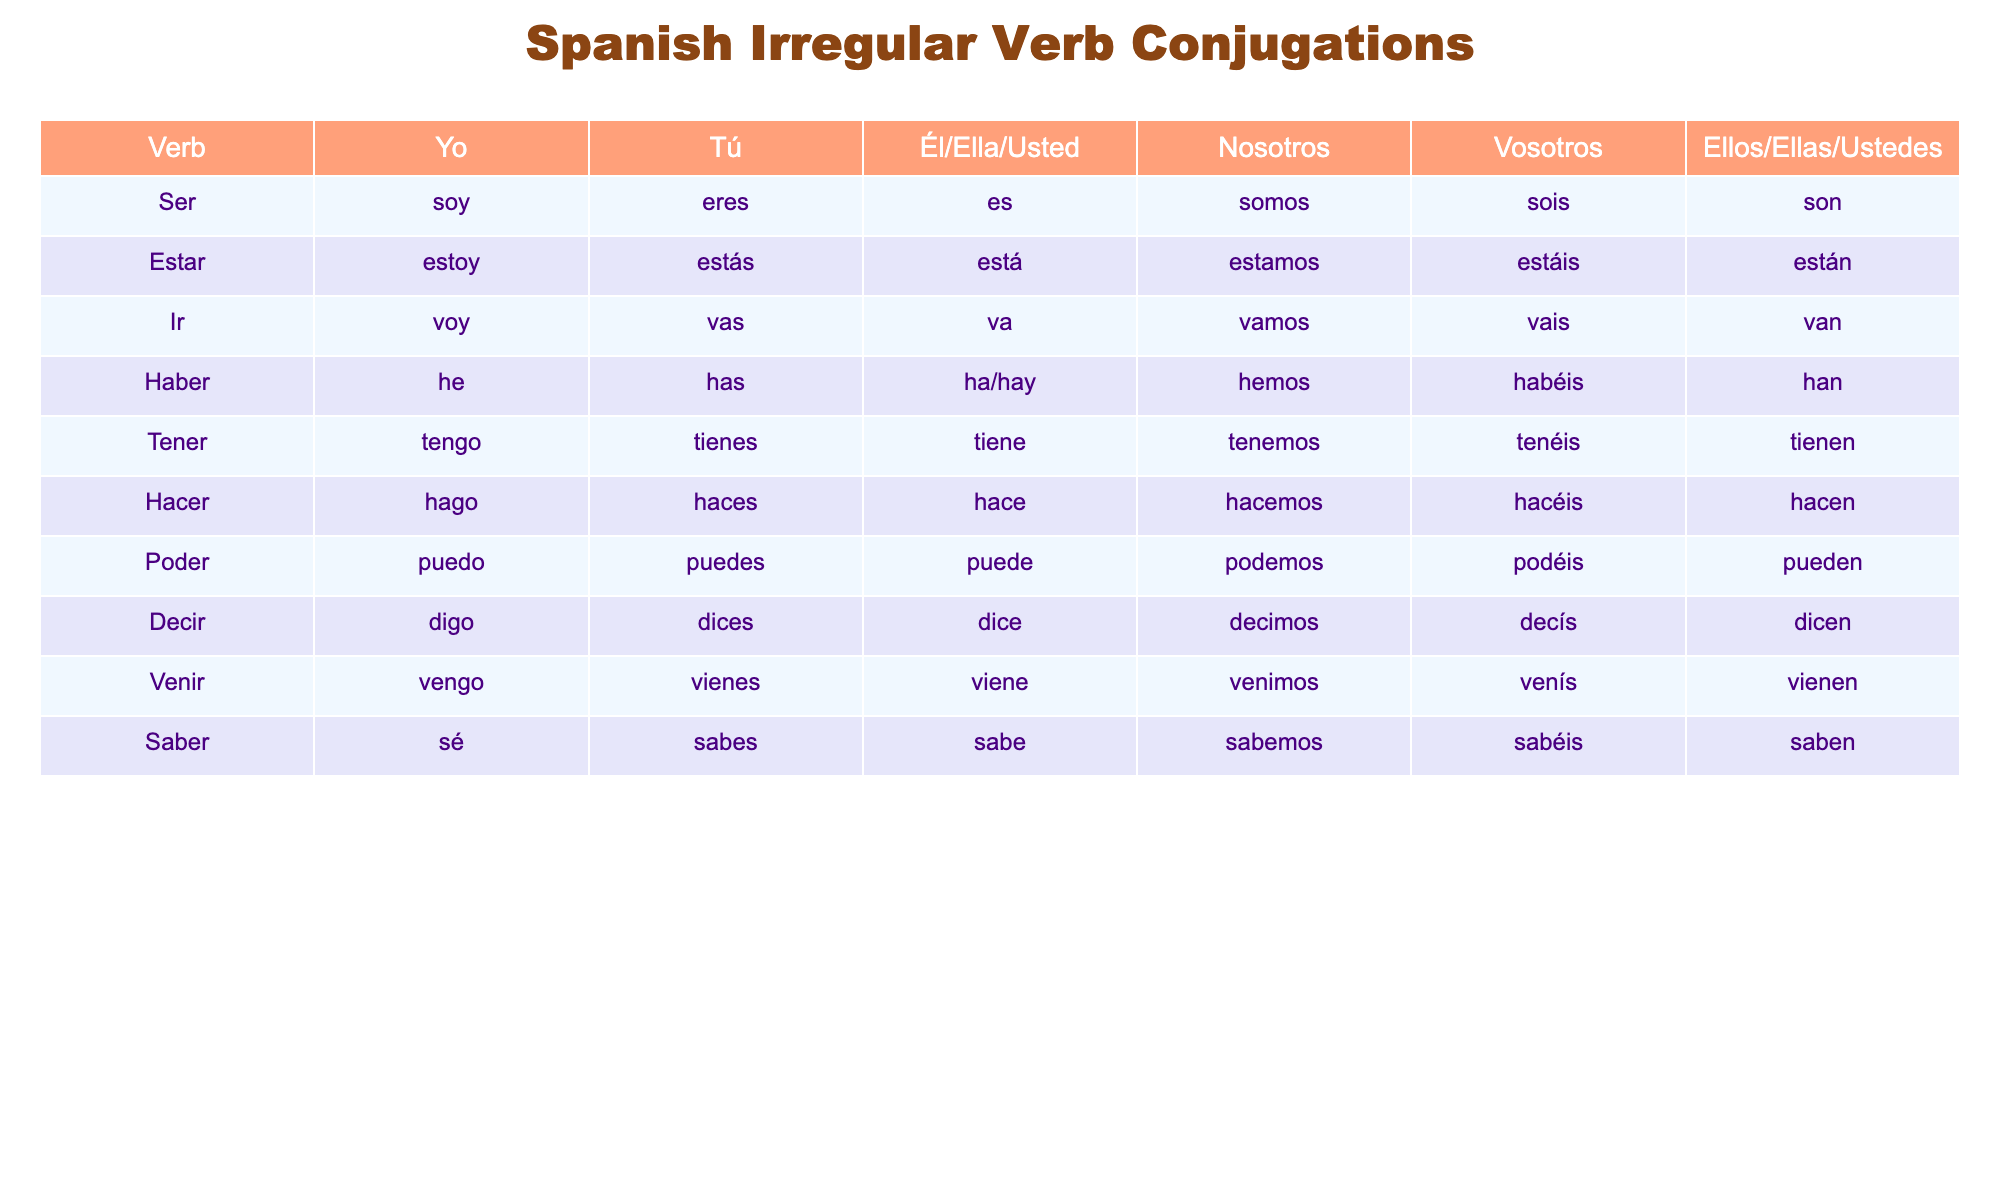What is the conjugation of the verb "haber" for "yo"? In the table, look under the column labeled "Yo" for the verb "Haber." It shows "he" as the conjugation.
Answer: he What is the tú form of the verb "tener"? Find "tener" in the table. The corresponding form for "tú" is "tienes."
Answer: tienes Which verb has the conjugation "son" for "ellos/ellas/ustedes"? Check the table for the row under "Ellos/Ellas/Ustedes" to find the verb that corresponds to "son." The verb is "ser."
Answer: ser Is the conjugation for "yo" of the verb "hacer" "hago"? Look at the table in the row for "hacer" under the "Yo" column, which shows "hago." Therefore, the statement is true.
Answer: Yes What are the first-person plural forms (nosotros) for the verbs "ir" and "venir"? Check the "Nosotros" column for both verbs. "Ir" conjugates to "vamos," and "venir" conjugates to "venimos."
Answer: vamos, venimos Are all the verbs listed in the table irregular? The table focuses on irregular verbs, so all the listed verbs are indeed irregular.
Answer: Yes Which verb has the same conjugation for "él/ella/usted" and "ellos/ellas/ustedes"? In the table, "haber" shows "ha/hay" for "él/ella/usted" and "han" for "ellos/ellas/ustedes," but they are not the same. Check this for all rows to see that none match this criteria in this format.
Answer: None What is the total number of irregular verbs listed in the table? Count the number of rows in the table, which are from "Ser" to "Saber," yielding 10 irregular verbs in total.
Answer: 10 Which of the verbs has the "tú" conjugation as "vas"? Review the table’s "Tú" column to see that "ir" has "vas."
Answer: ir If you take all the "vosotros" forms from the verbs, what are they? Look at the "Vosotros" column in the table to compile the forms: "sois," "estáis," "vais," "habéis," "tenéis," "hacéis," "podéis," "decís," "venís," and "sabéis."
Answer: sois, estáis, vais, habéis, tenéis, hacéis, podéis, decís, venís, sabéis 